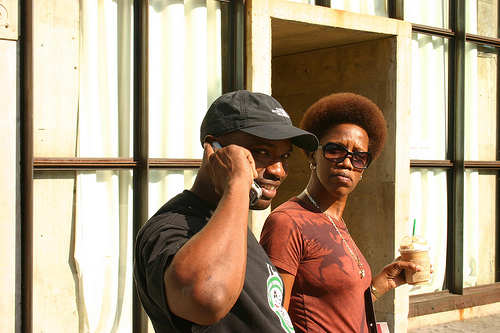Can you describe their expressions or mood? The man appears occupied with his phone conversation, possibly discussing something important, as indicated by his focused gaze. The woman has a thoughtful or serious expression, suggesting that she is either listening intently to something or deeply engrossed in her thoughts. 